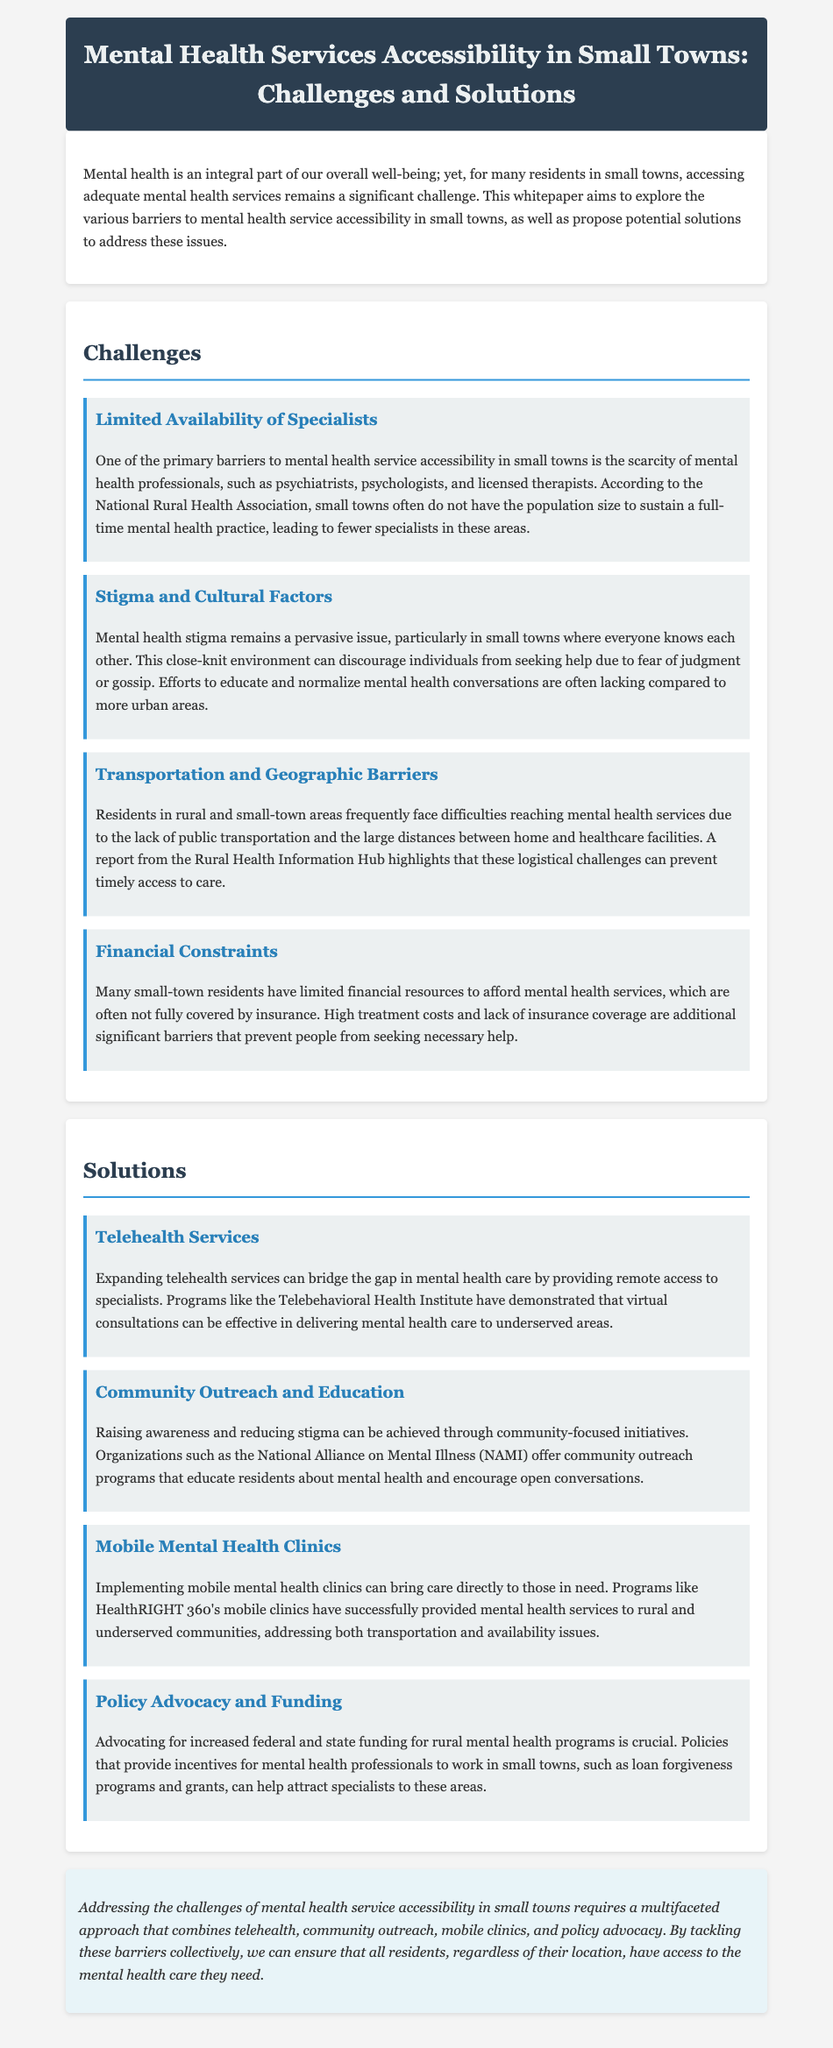What is the title of the whitepaper? The title of the whitepaper is presented at the top of the document and provides the main topic being discussed.
Answer: Mental Health Services Accessibility in Small Towns: Challenges and Solutions How many challenges are listed in the document? The document enumerates the challenges related to mental health service accessibility in small towns.
Answer: Four What is one of the primary barriers to mental health service accessibility? The document identifies specific challenges, one of which is mentioned in the 'Challenges' section.
Answer: Limited Availability of Specialists Which organization offers community outreach programs? The document cites an organization involved in community outreach and education initiatives to raise mental health awareness.
Answer: National Alliance on Mental Illness (NAMI) What solution is proposed for addressing transportation barriers? The document mentions a specific type of service that tackles logistical issues with accessing mental health care in small towns.
Answer: Mobile Mental Health Clinics What type of services can bridge the gap in mental health care? The solution section of the document discusses a modern approach for delivering mental health care remotely.
Answer: Telehealth Services What is a key reason for mental health stigma in small towns? The document highlights social dynamics that contribute to hesitance in pursuing mental health services.
Answer: Fear of judgment or gossip What advocacy is crucial according to the document? The solutions section points out essential advocacy that supports mental health programs at a governmental level.
Answer: Policy Advocacy and Funding 